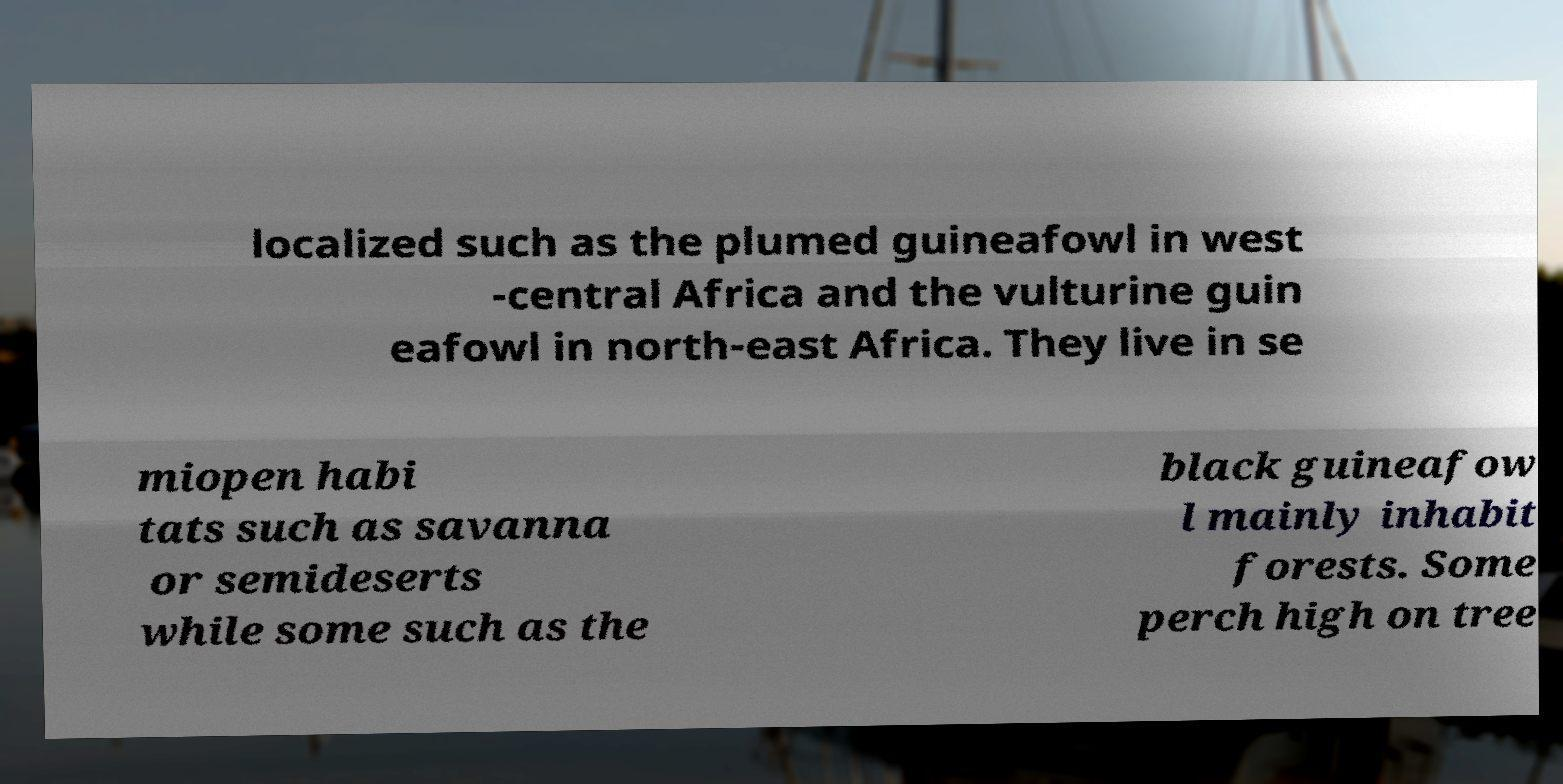Could you extract and type out the text from this image? localized such as the plumed guineafowl in west -central Africa and the vulturine guin eafowl in north-east Africa. They live in se miopen habi tats such as savanna or semideserts while some such as the black guineafow l mainly inhabit forests. Some perch high on tree 